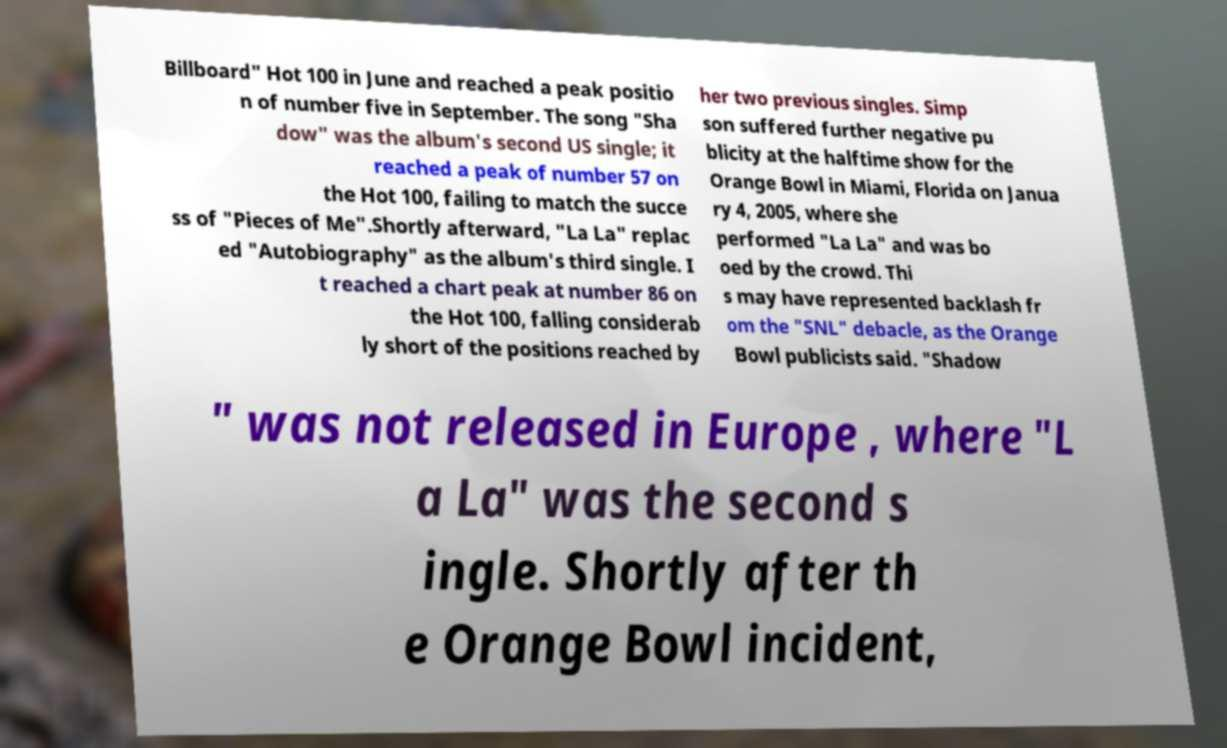Could you assist in decoding the text presented in this image and type it out clearly? Billboard" Hot 100 in June and reached a peak positio n of number five in September. The song "Sha dow" was the album's second US single; it reached a peak of number 57 on the Hot 100, failing to match the succe ss of "Pieces of Me".Shortly afterward, "La La" replac ed "Autobiography" as the album's third single. I t reached a chart peak at number 86 on the Hot 100, falling considerab ly short of the positions reached by her two previous singles. Simp son suffered further negative pu blicity at the halftime show for the Orange Bowl in Miami, Florida on Janua ry 4, 2005, where she performed "La La" and was bo oed by the crowd. Thi s may have represented backlash fr om the "SNL" debacle, as the Orange Bowl publicists said. "Shadow " was not released in Europe , where "L a La" was the second s ingle. Shortly after th e Orange Bowl incident, 